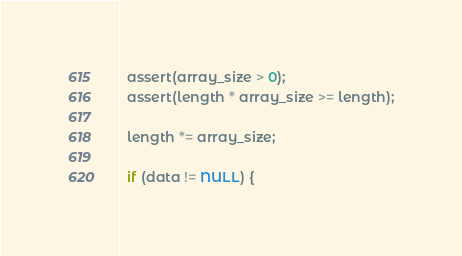<code> <loc_0><loc_0><loc_500><loc_500><_C++_>
  assert(array_size > 0);
  assert(length * array_size >= length);

  length *= array_size;

  if (data != NULL) {</code> 